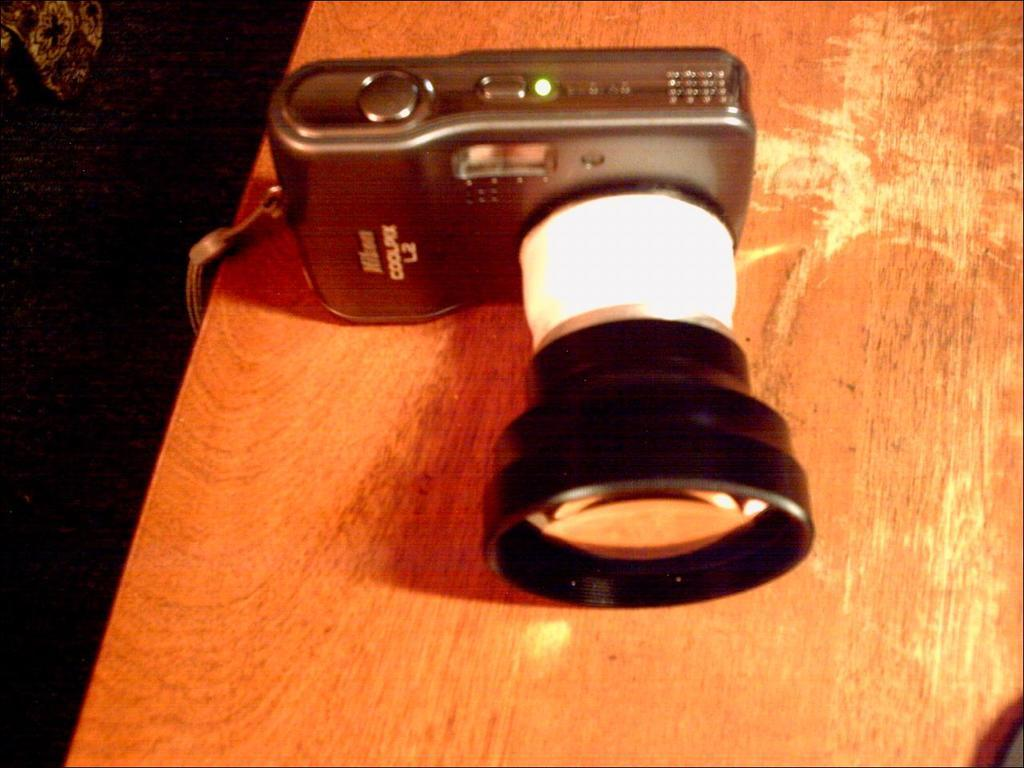What is the main object in the center of the image? There is a camera in the center of the image. What is located at the bottom of the image? There is a table at the bottom of the image. Can you describe the object in the top left corner of the image? There appears to be a cloth in the top left corner of the image. What color is the background of the image? The background of the image is black. What type of wine is being poured from the camera in the image? There is no wine present in the image, and the camera is not pouring anything. 